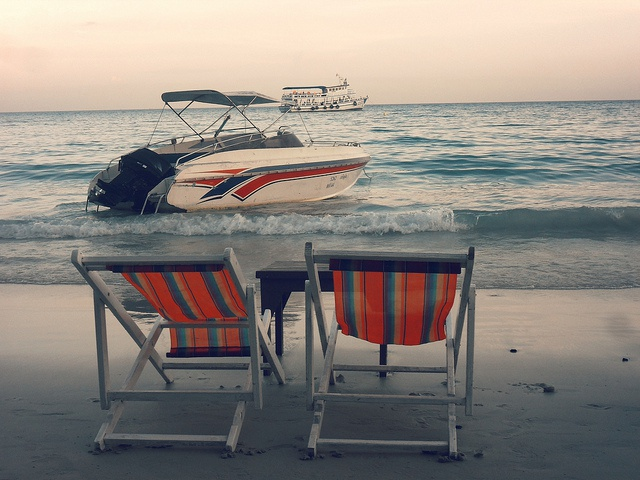Describe the objects in this image and their specific colors. I can see chair in beige, gray, black, and purple tones, chair in beige, gray, black, purple, and brown tones, boat in beige, darkgray, black, gray, and tan tones, dining table in beige, black, gray, and darkgray tones, and boat in beige, darkgray, tan, and gray tones in this image. 